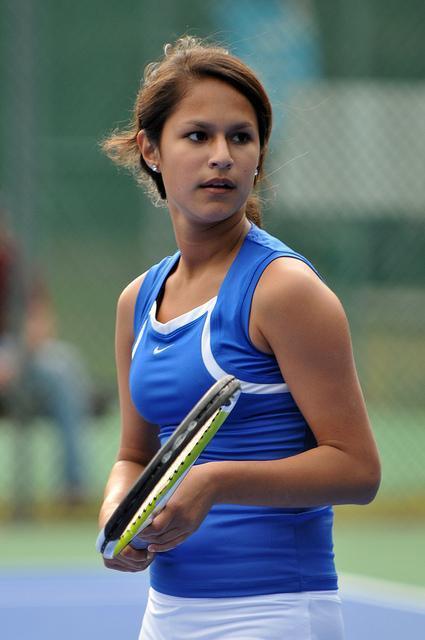How many tennis rackets are there?
Give a very brief answer. 1. 